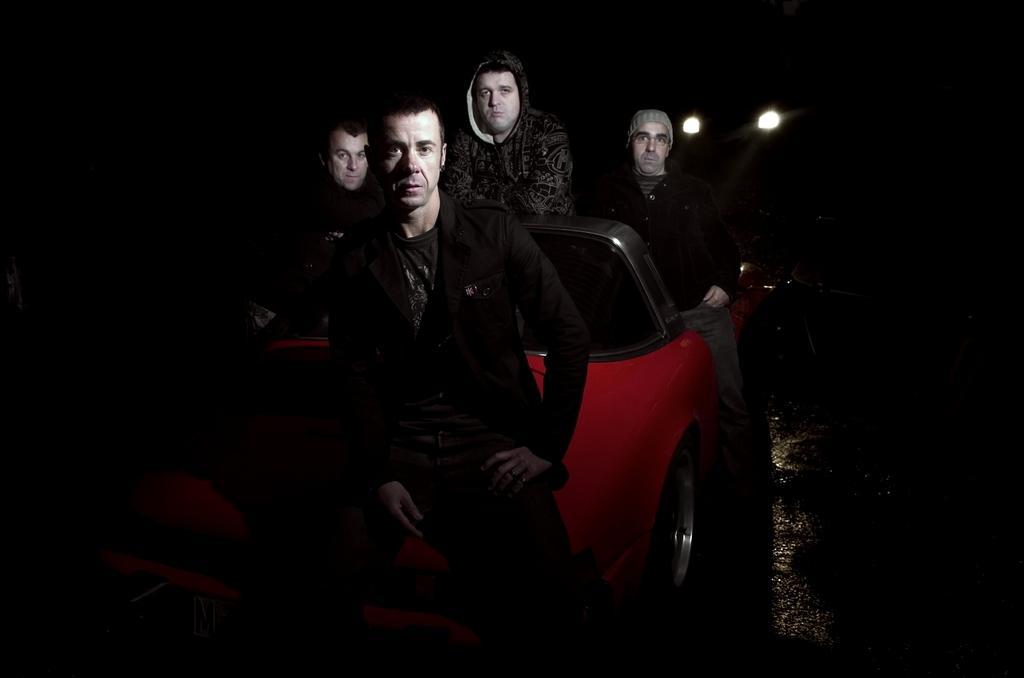Could you give a brief overview of what you see in this image? In this image there are group of persons who are sitting on the red car. 